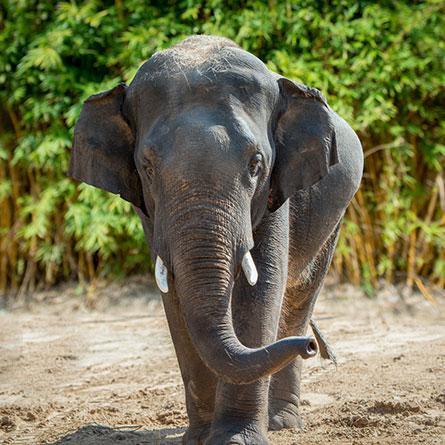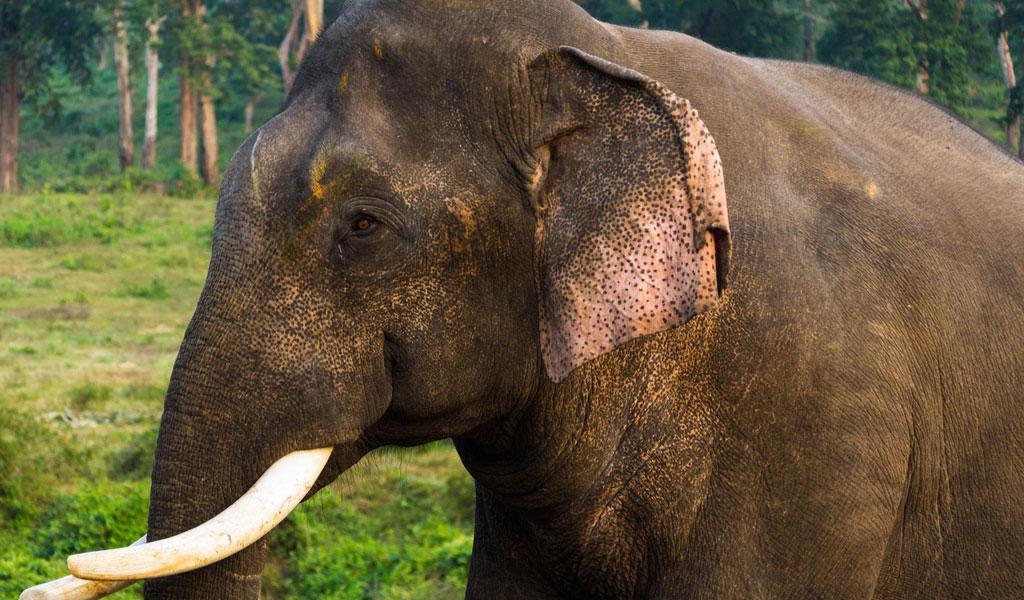The first image is the image on the left, the second image is the image on the right. Analyze the images presented: Is the assertion "All elephants shown have tusks and exactly one elephant faces the camera." valid? Answer yes or no. Yes. The first image is the image on the left, the second image is the image on the right. Analyze the images presented: Is the assertion "The left image contains two elephants touching their heads to each others." valid? Answer yes or no. No. 